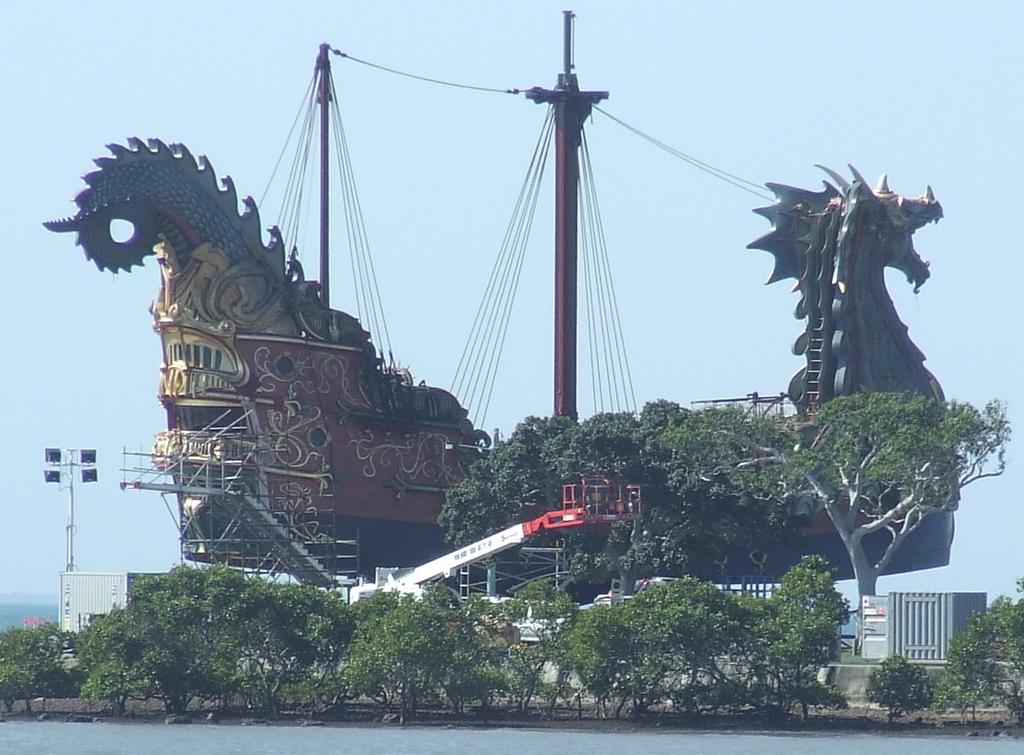What is the main subject in the center of the image? There is a dragon-shaped ship in the center of the image. What objects can be seen in the image besides the dragon-shaped ship? There are poles, wires, trees, plants, a staircase, a fence, a crane, and a road visible in the image. What is the sky's condition in the image? The sky is visible in the background of the image. What type of bean is being used to create the dragon-shaped ship in the image? There is no bean present in the image, and the dragon-shaped ship is not made of beans. 